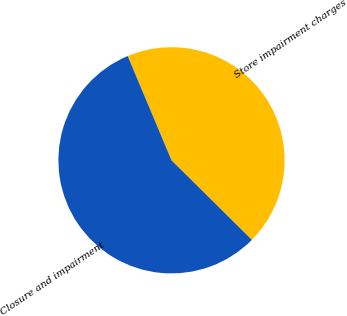<chart> <loc_0><loc_0><loc_500><loc_500><pie_chart><fcel>Store impairment charges<fcel>Closure and impairment<nl><fcel>43.75%<fcel>56.25%<nl></chart> 